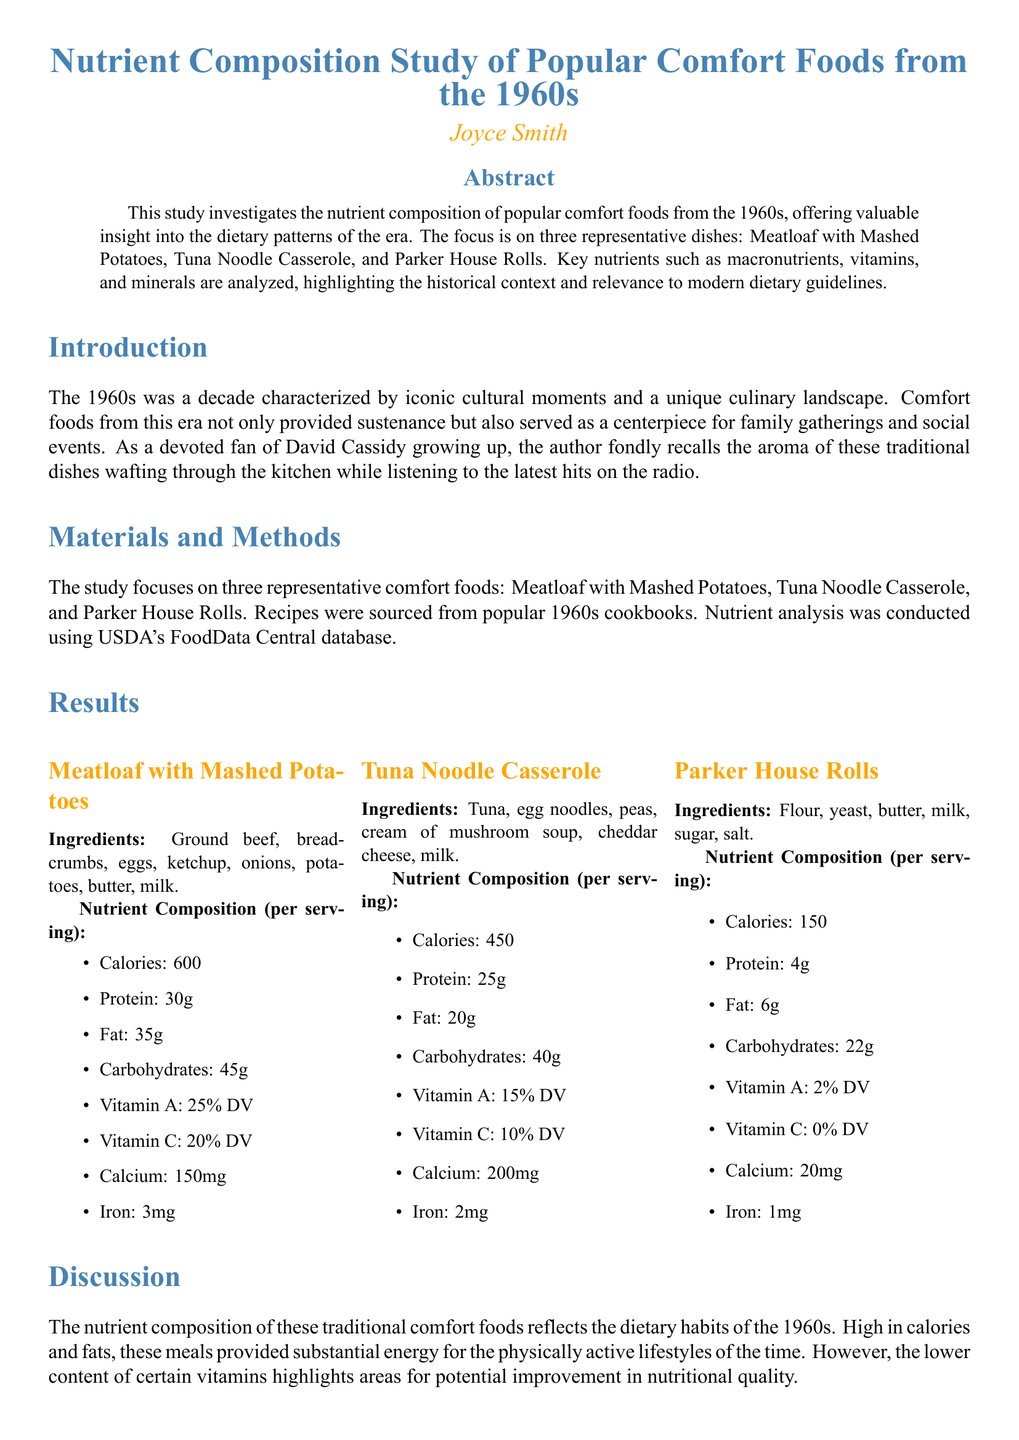What are the three comfort foods studied? The document states that the study focuses on Meatloaf with Mashed Potatoes, Tuna Noodle Casserole, and Parker House Rolls.
Answer: Meatloaf with Mashed Potatoes, Tuna Noodle Casserole, Parker House Rolls How many grams of protein are in Tuna Noodle Casserole? The nutrient composition for Tuna Noodle Casserole indicates it contains 25 grams of protein per serving.
Answer: 25g What year is the Betty Crocker cookbook mentioned? The document references Betty Crocker's Picture Cook Book as published in 1950.
Answer: 1950 What is the calorie content of Meatloaf with Mashed Potatoes? According to the document, Meatloaf with Mashed Potatoes has a calorie content of 600 calories per serving.
Answer: 600 Which nutrient had the highest percentage Daily Value in Meatloaf with Mashed Potatoes? The document shows that Vitamin A has the highest percentage Daily Value at 25% in Meatloaf with Mashed Potatoes.
Answer: 25% DV What was the focus of the study? The abstract specifies that the study investigates the nutrient composition of popular comfort foods from the 1960s.
Answer: Nutrient composition of popular comfort foods from the 1960s What is the conclusion about the comfort foods from the 1960s? The conclusion states that these foods offer rich flavors and substantial nutrients but also reflect dietary indulgences of the time.
Answer: Reflect dietary indulgences of the time Where was the nutrient analysis sourced from? The materials and methods section mentions that nutrient analysis was conducted using USDA's FoodData Central database.
Answer: USDA's FoodData Central How many milligrams of calcium are in Parker House Rolls? The nutrient composition for Parker House Rolls indicates it contains 20 milligrams of calcium per serving.
Answer: 20mg 